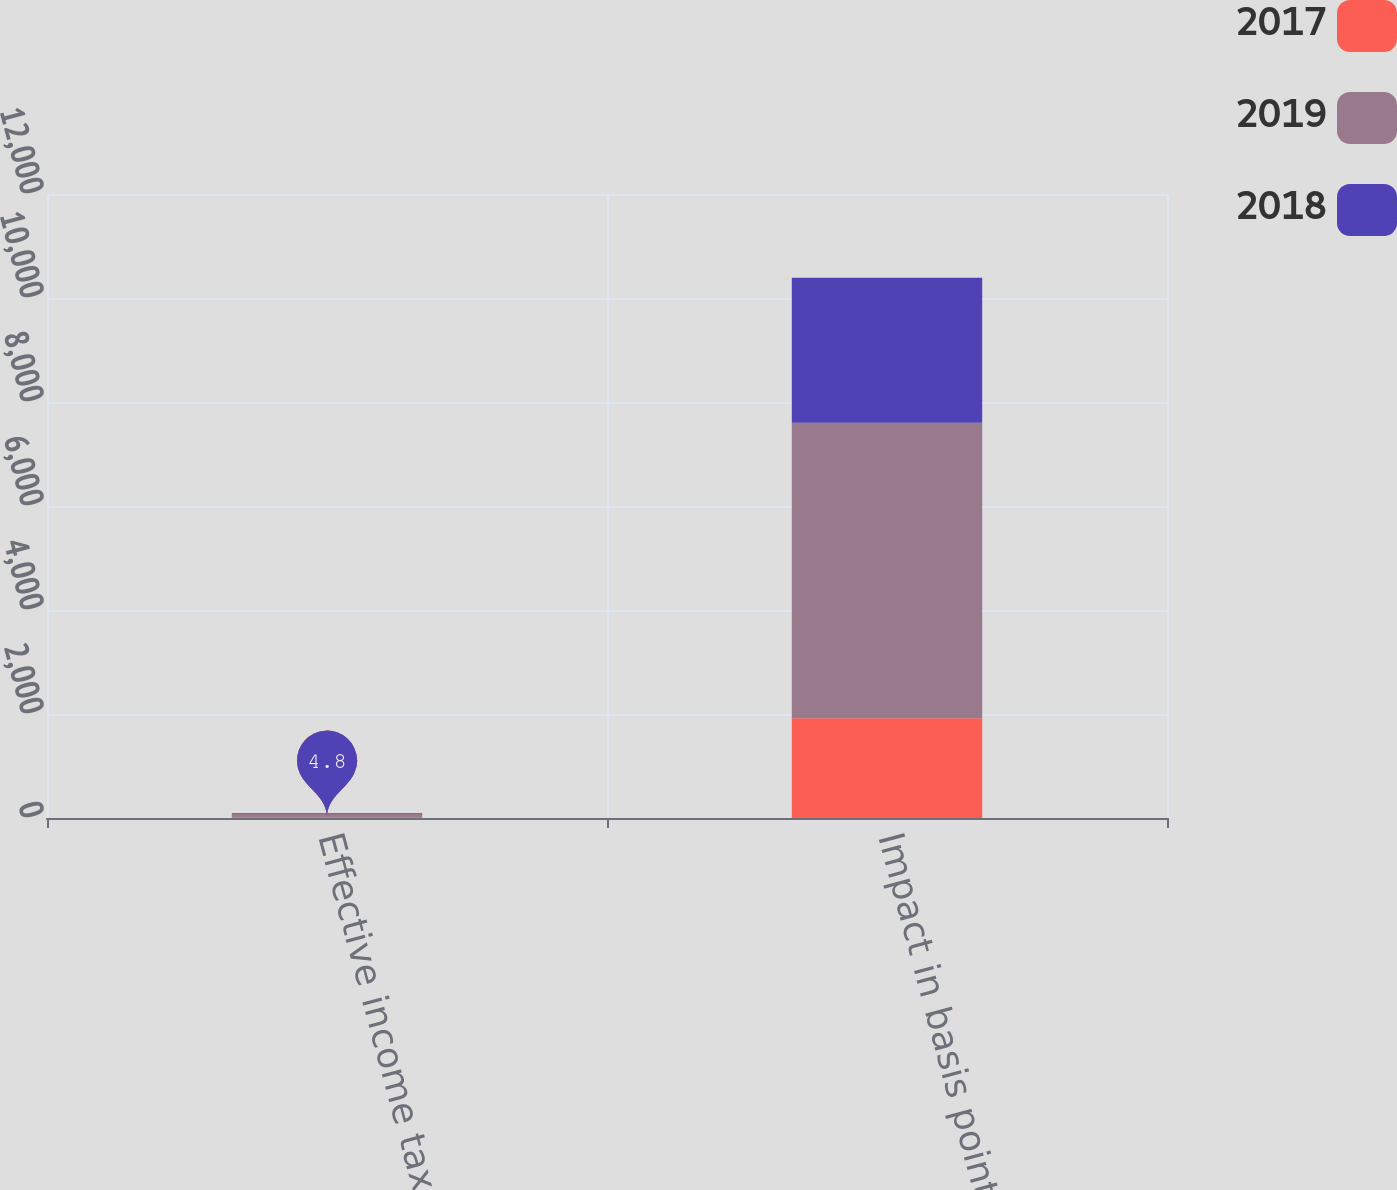<chart> <loc_0><loc_0><loc_500><loc_500><stacked_bar_chart><ecel><fcel>Effective income tax rate<fcel>Impact in basis points from<nl><fcel>2017<fcel>4.8<fcel>1920<nl><fcel>2019<fcel>73.5<fcel>5680<nl><fcel>2018<fcel>12.7<fcel>2790<nl></chart> 